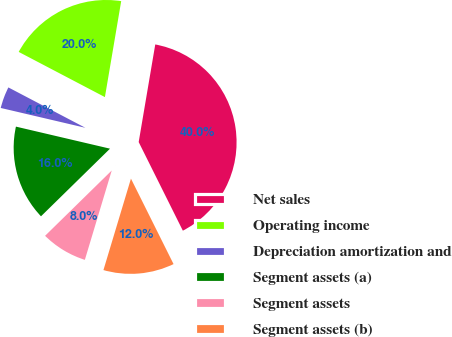Convert chart. <chart><loc_0><loc_0><loc_500><loc_500><pie_chart><fcel>Net sales<fcel>Operating income<fcel>Depreciation amortization and<fcel>Segment assets (a)<fcel>Segment assets<fcel>Segment assets (b)<nl><fcel>39.96%<fcel>19.99%<fcel>4.02%<fcel>16.0%<fcel>8.01%<fcel>12.01%<nl></chart> 